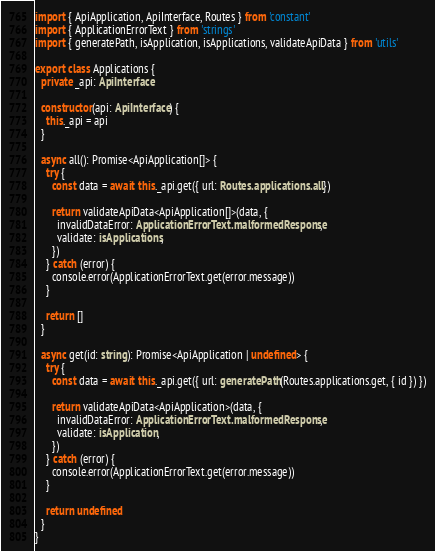<code> <loc_0><loc_0><loc_500><loc_500><_TypeScript_>import { ApiApplication, ApiInterface, Routes } from 'constant'
import { ApplicationErrorText } from 'strings'
import { generatePath, isApplication, isApplications, validateApiData } from 'utils'

export class Applications {
  private _api: ApiInterface

  constructor(api: ApiInterface) {
    this._api = api
  }

  async all(): Promise<ApiApplication[]> {
    try {
      const data = await this._api.get({ url: Routes.applications.all })

      return validateApiData<ApiApplication[]>(data, {
        invalidDataError: ApplicationErrorText.malformedResponse,
        validate: isApplications,
      })
    } catch (error) {
      console.error(ApplicationErrorText.get(error.message))
    }

    return []
  }

  async get(id: string): Promise<ApiApplication | undefined> {
    try {
      const data = await this._api.get({ url: generatePath(Routes.applications.get, { id }) })

      return validateApiData<ApiApplication>(data, {
        invalidDataError: ApplicationErrorText.malformedResponse,
        validate: isApplication,
      })
    } catch (error) {
      console.error(ApplicationErrorText.get(error.message))
    }

    return undefined
  }
}
</code> 